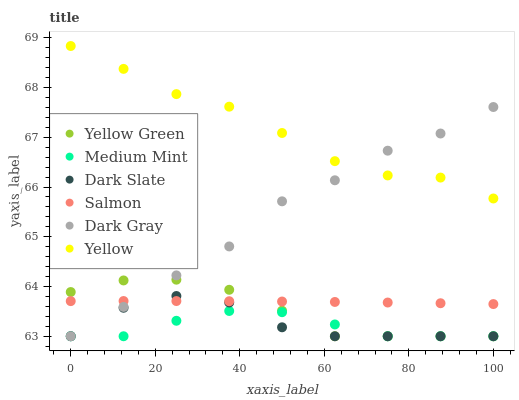Does Medium Mint have the minimum area under the curve?
Answer yes or no. Yes. Does Yellow have the maximum area under the curve?
Answer yes or no. Yes. Does Yellow Green have the minimum area under the curve?
Answer yes or no. No. Does Yellow Green have the maximum area under the curve?
Answer yes or no. No. Is Salmon the smoothest?
Answer yes or no. Yes. Is Dark Slate the roughest?
Answer yes or no. Yes. Is Yellow Green the smoothest?
Answer yes or no. No. Is Yellow Green the roughest?
Answer yes or no. No. Does Medium Mint have the lowest value?
Answer yes or no. Yes. Does Salmon have the lowest value?
Answer yes or no. No. Does Yellow have the highest value?
Answer yes or no. Yes. Does Yellow Green have the highest value?
Answer yes or no. No. Is Yellow Green less than Yellow?
Answer yes or no. Yes. Is Yellow greater than Yellow Green?
Answer yes or no. Yes. Does Yellow Green intersect Dark Gray?
Answer yes or no. Yes. Is Yellow Green less than Dark Gray?
Answer yes or no. No. Is Yellow Green greater than Dark Gray?
Answer yes or no. No. Does Yellow Green intersect Yellow?
Answer yes or no. No. 